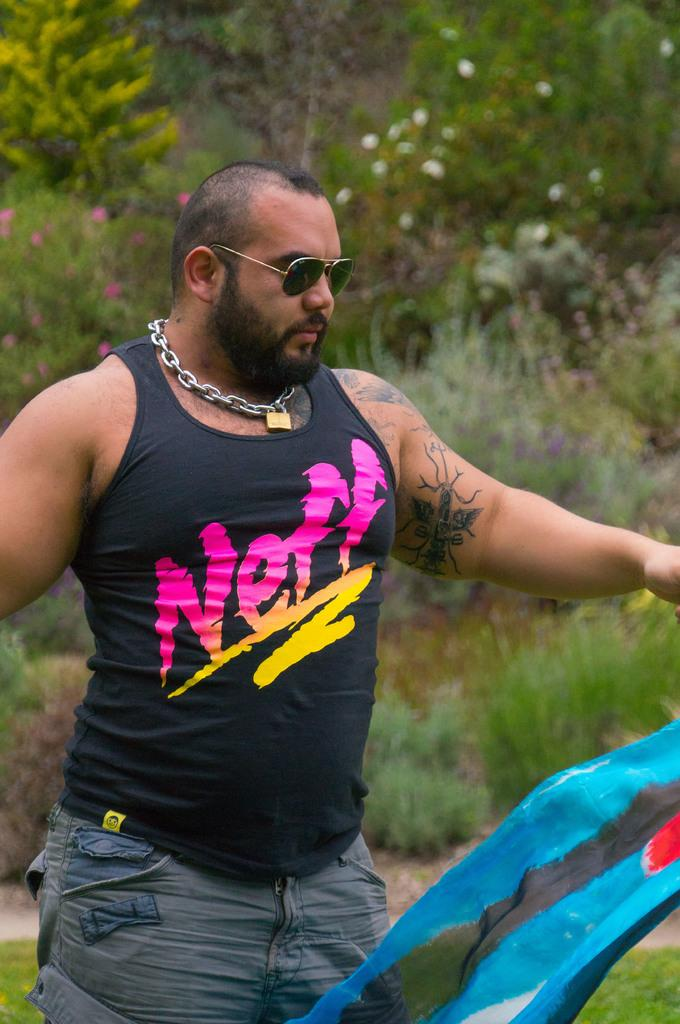What is the main subject of the image? There is a man standing in the image. Can you describe the man's appearance? The man is wearing glasses. What type of natural elements can be seen in the image? There are trees and flowers visible in the image. How many bricks can be seen in the man's pocket in the image? There are no bricks present in the image, and the man's pockets are not visible. 